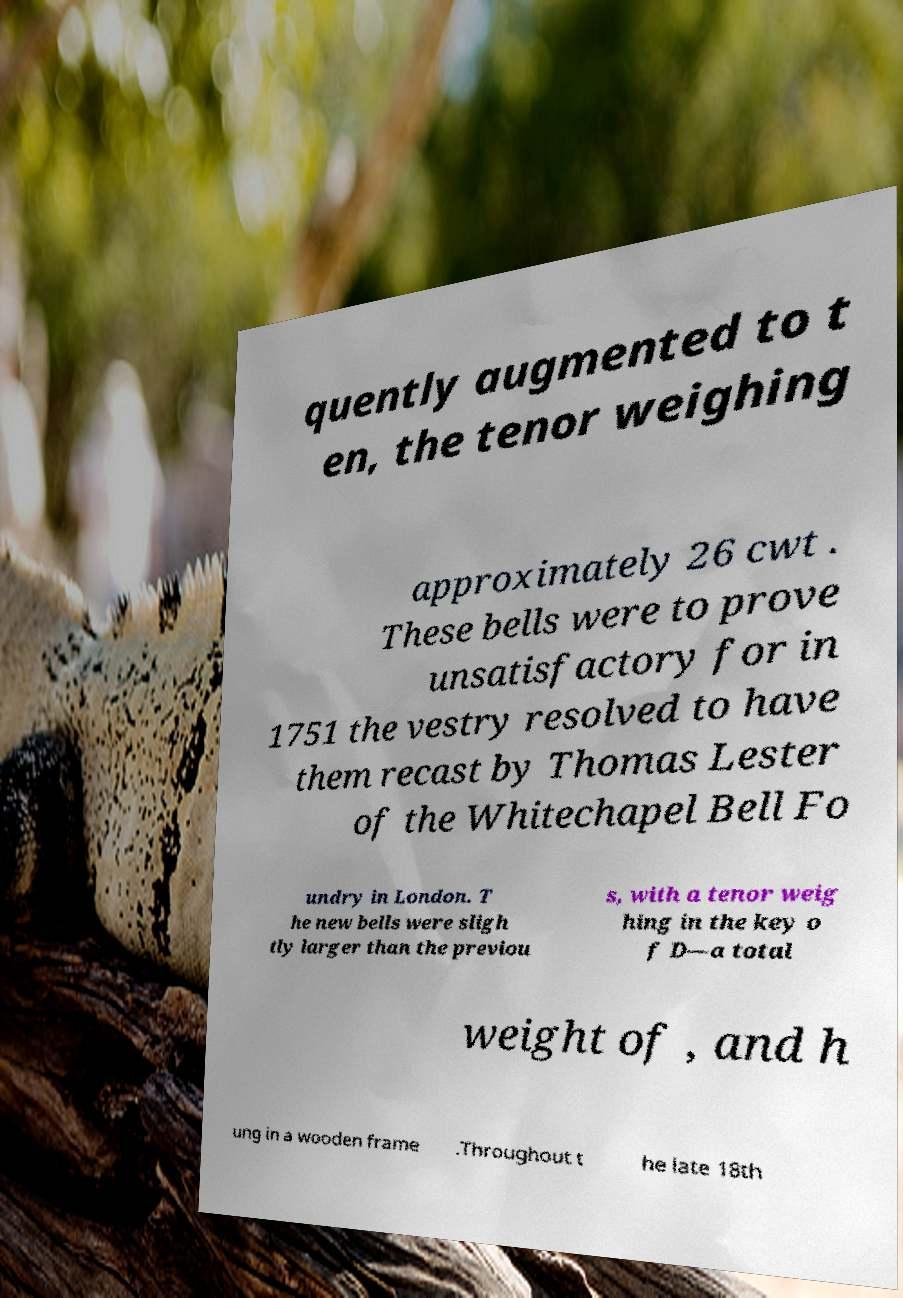Please read and relay the text visible in this image. What does it say? quently augmented to t en, the tenor weighing approximately 26 cwt . These bells were to prove unsatisfactory for in 1751 the vestry resolved to have them recast by Thomas Lester of the Whitechapel Bell Fo undry in London. T he new bells were sligh tly larger than the previou s, with a tenor weig hing in the key o f D—a total weight of , and h ung in a wooden frame .Throughout t he late 18th 